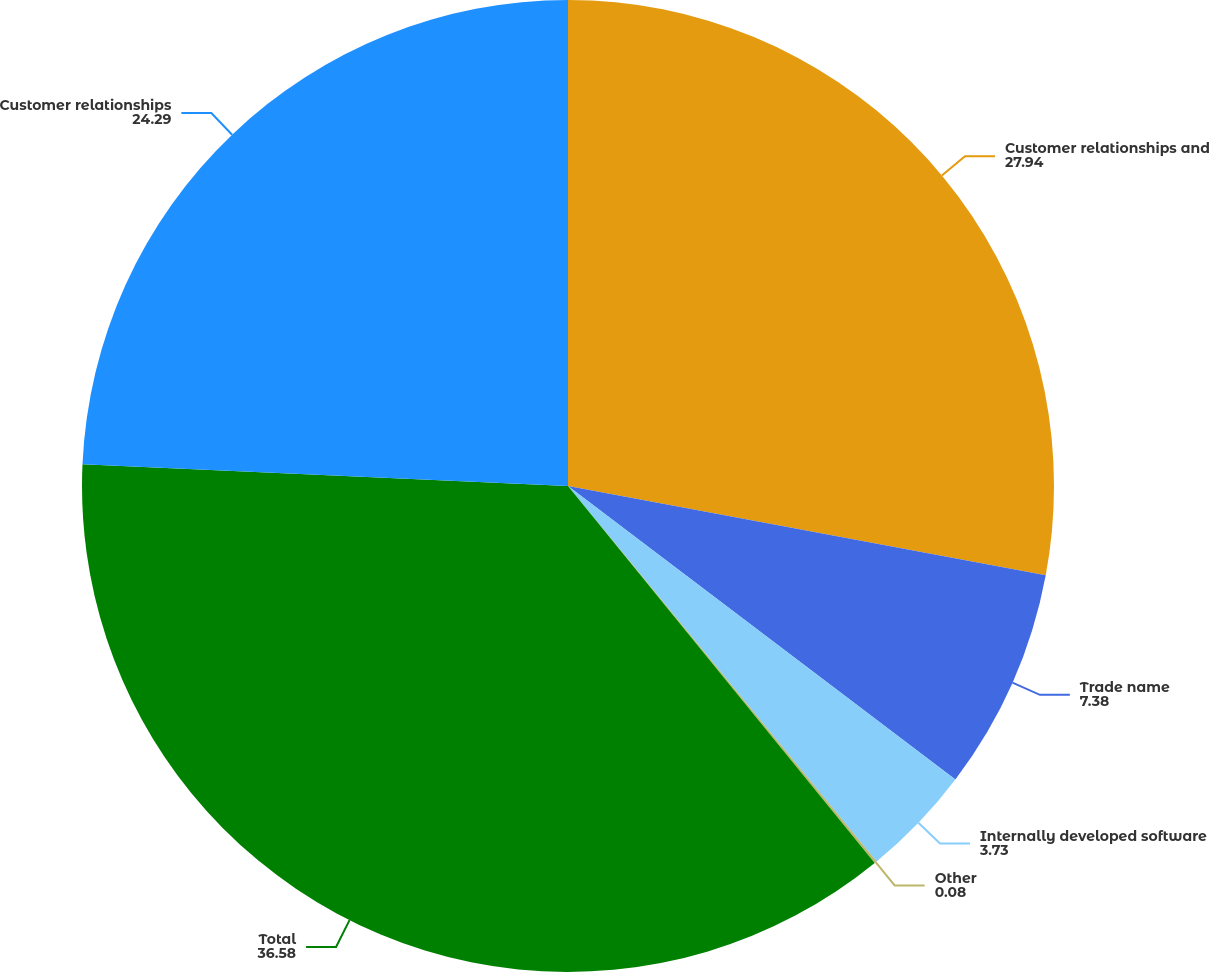<chart> <loc_0><loc_0><loc_500><loc_500><pie_chart><fcel>Customer relationships and<fcel>Trade name<fcel>Internally developed software<fcel>Other<fcel>Total<fcel>Customer relationships<nl><fcel>27.94%<fcel>7.38%<fcel>3.73%<fcel>0.08%<fcel>36.58%<fcel>24.29%<nl></chart> 